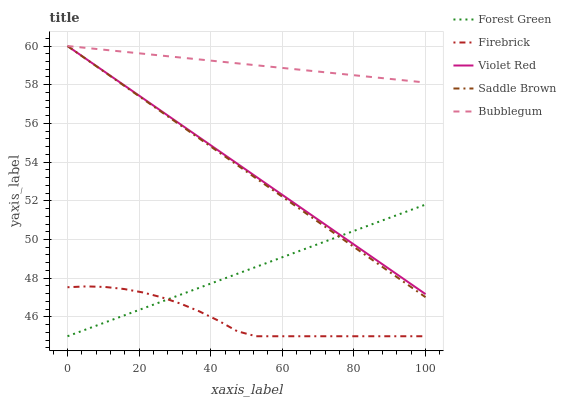Does Firebrick have the minimum area under the curve?
Answer yes or no. Yes. Does Bubblegum have the maximum area under the curve?
Answer yes or no. Yes. Does Forest Green have the minimum area under the curve?
Answer yes or no. No. Does Forest Green have the maximum area under the curve?
Answer yes or no. No. Is Violet Red the smoothest?
Answer yes or no. Yes. Is Firebrick the roughest?
Answer yes or no. Yes. Is Forest Green the smoothest?
Answer yes or no. No. Is Forest Green the roughest?
Answer yes or no. No. Does Forest Green have the lowest value?
Answer yes or no. Yes. Does Bubblegum have the lowest value?
Answer yes or no. No. Does Saddle Brown have the highest value?
Answer yes or no. Yes. Does Forest Green have the highest value?
Answer yes or no. No. Is Forest Green less than Bubblegum?
Answer yes or no. Yes. Is Bubblegum greater than Forest Green?
Answer yes or no. Yes. Does Saddle Brown intersect Bubblegum?
Answer yes or no. Yes. Is Saddle Brown less than Bubblegum?
Answer yes or no. No. Is Saddle Brown greater than Bubblegum?
Answer yes or no. No. Does Forest Green intersect Bubblegum?
Answer yes or no. No. 